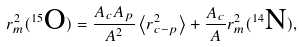Convert formula to latex. <formula><loc_0><loc_0><loc_500><loc_500>r _ { m } ^ { 2 } ( ^ { 1 5 } { \text  O})=\frac{A_{c} A _ { p } } { A ^ { 2 } } \left \langle r _ { c - p } ^ { 2 } \right \rangle + \frac { A _ { c } } { A } r _ { m } ^ { 2 } ( ^ { 1 4 } { \text  N}) ,</formula> 